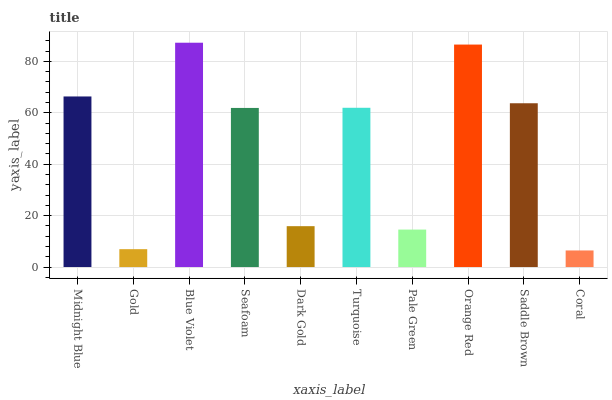Is Coral the minimum?
Answer yes or no. Yes. Is Blue Violet the maximum?
Answer yes or no. Yes. Is Gold the minimum?
Answer yes or no. No. Is Gold the maximum?
Answer yes or no. No. Is Midnight Blue greater than Gold?
Answer yes or no. Yes. Is Gold less than Midnight Blue?
Answer yes or no. Yes. Is Gold greater than Midnight Blue?
Answer yes or no. No. Is Midnight Blue less than Gold?
Answer yes or no. No. Is Turquoise the high median?
Answer yes or no. Yes. Is Seafoam the low median?
Answer yes or no. Yes. Is Pale Green the high median?
Answer yes or no. No. Is Dark Gold the low median?
Answer yes or no. No. 